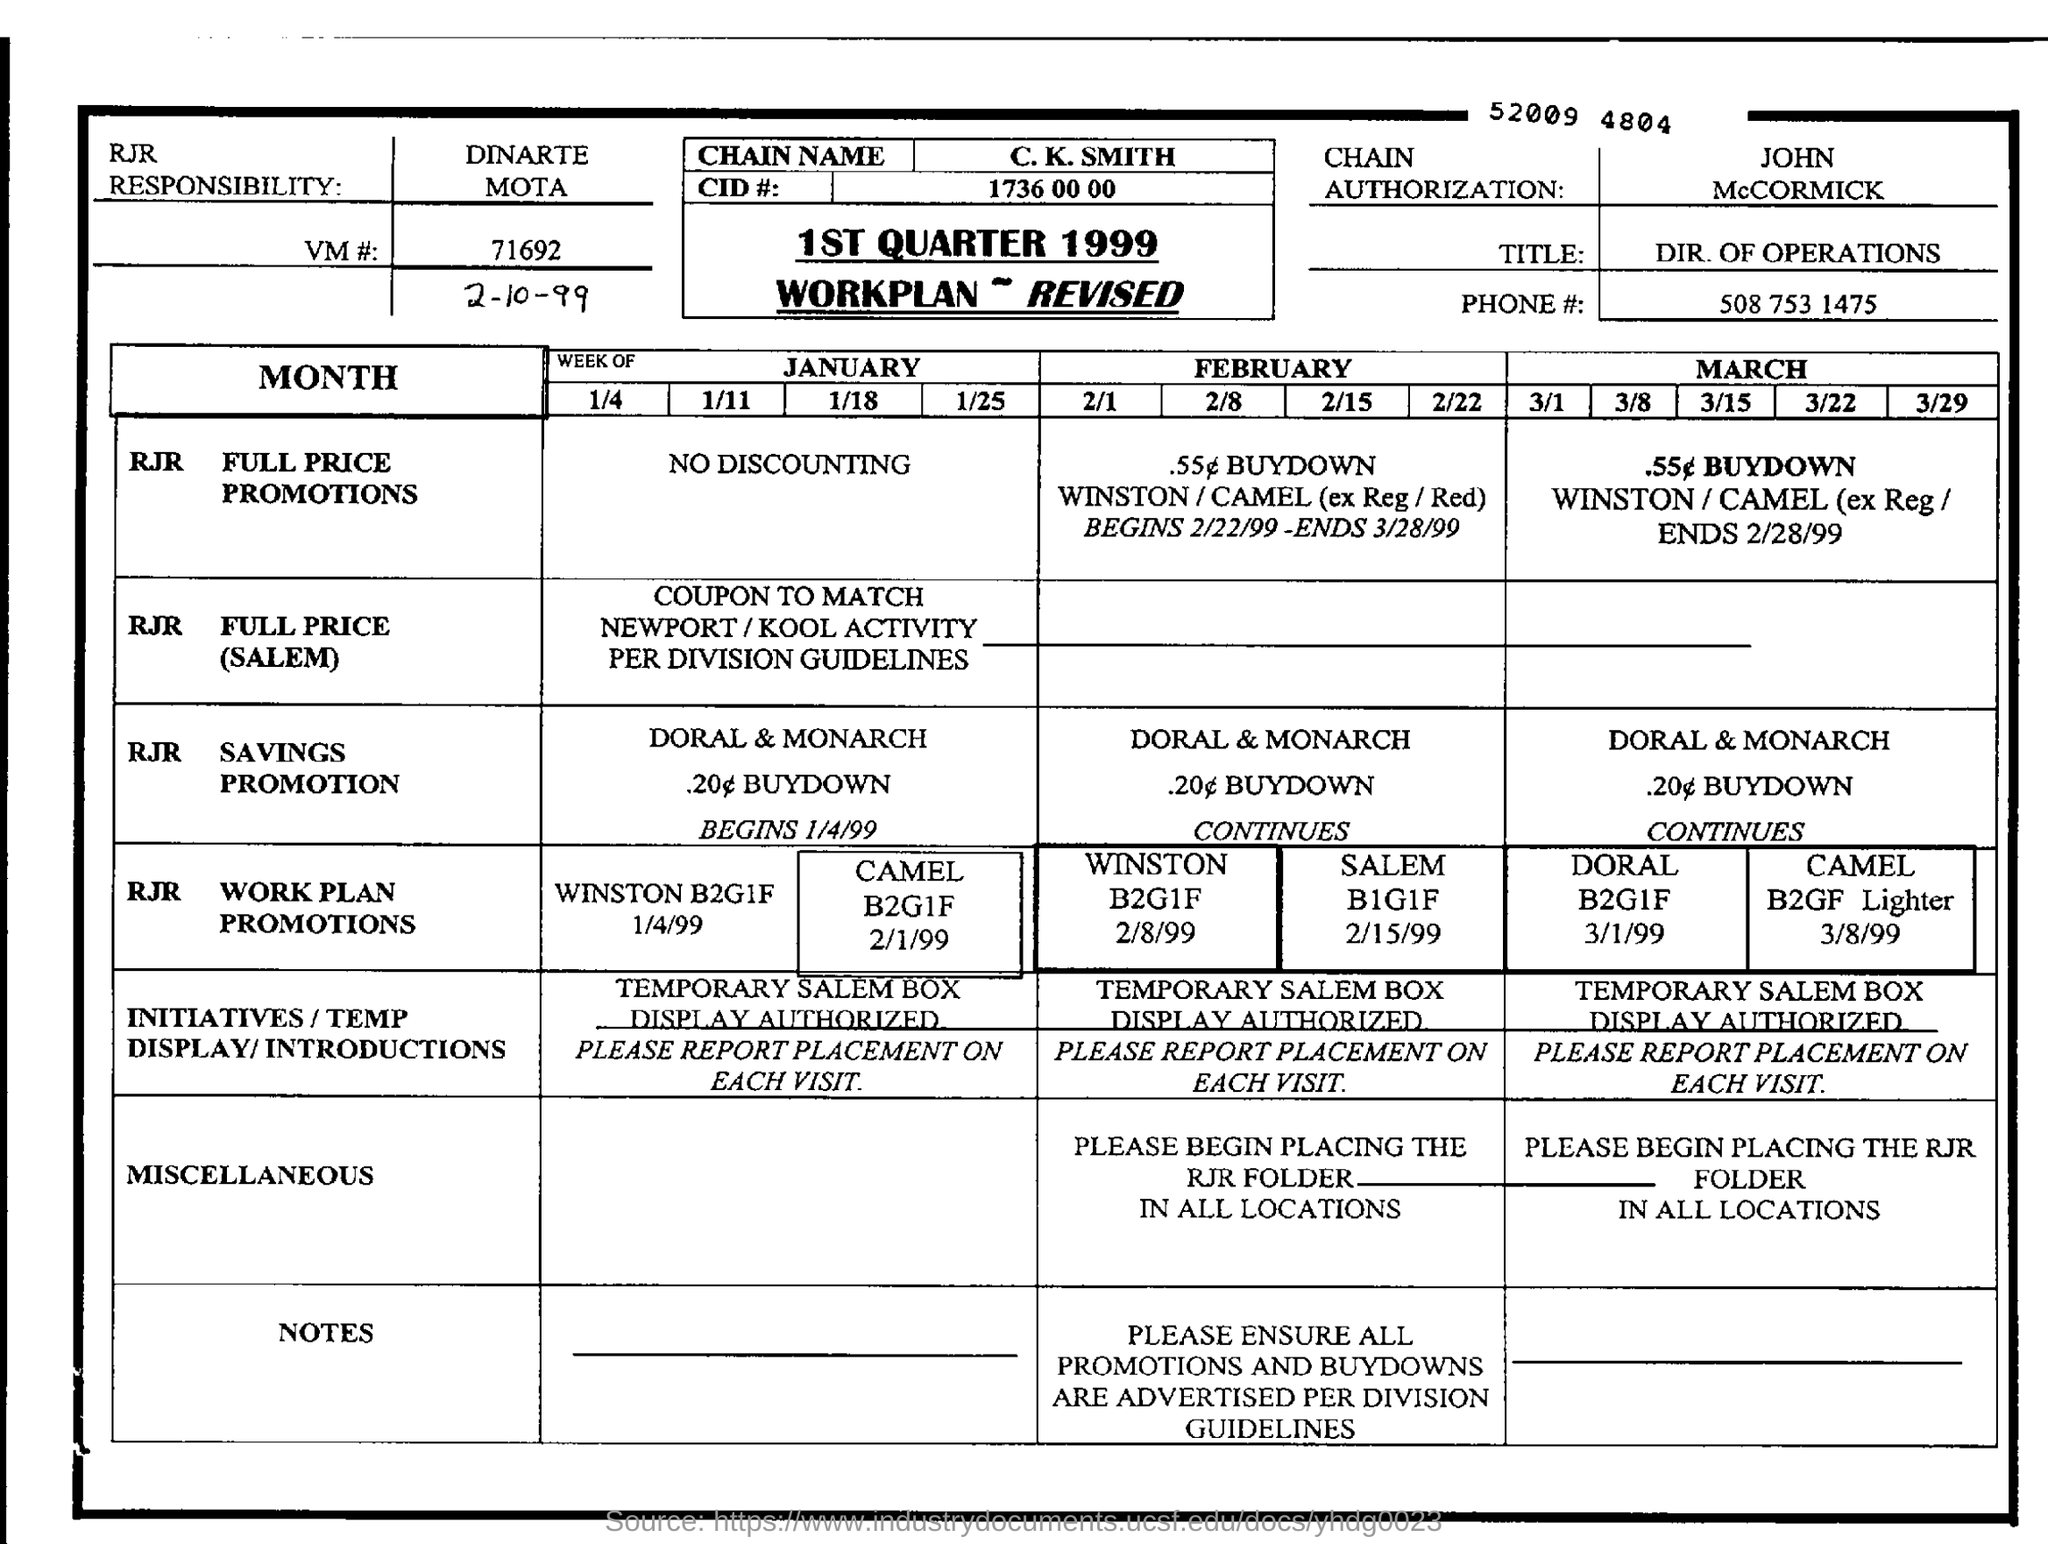List a handful of essential elements in this visual. The value mentioned in the CID# is 1736 00 00. What is the VM number? It is 71692... 